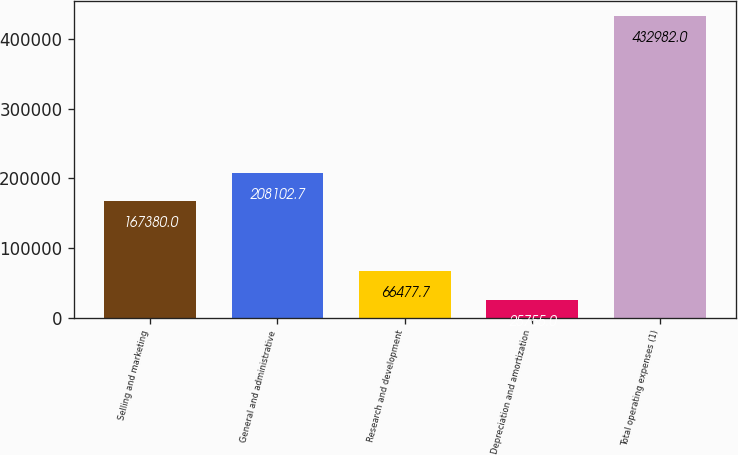Convert chart to OTSL. <chart><loc_0><loc_0><loc_500><loc_500><bar_chart><fcel>Selling and marketing<fcel>General and administrative<fcel>Research and development<fcel>Depreciation and amortization<fcel>Total operating expenses (1)<nl><fcel>167380<fcel>208103<fcel>66477.7<fcel>25755<fcel>432982<nl></chart> 